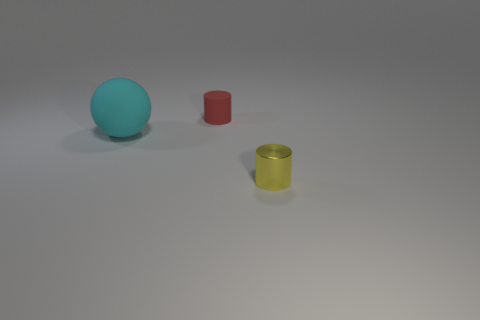Add 2 big gray matte blocks. How many objects exist? 5 Subtract all purple balls. How many gray cylinders are left? 0 Subtract all spheres. Subtract all rubber spheres. How many objects are left? 1 Add 3 cylinders. How many cylinders are left? 5 Add 1 tiny yellow cylinders. How many tiny yellow cylinders exist? 2 Subtract 1 yellow cylinders. How many objects are left? 2 Subtract all balls. How many objects are left? 2 Subtract all purple cylinders. Subtract all blue blocks. How many cylinders are left? 2 